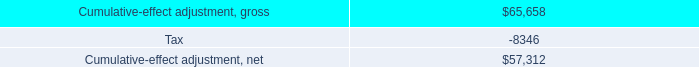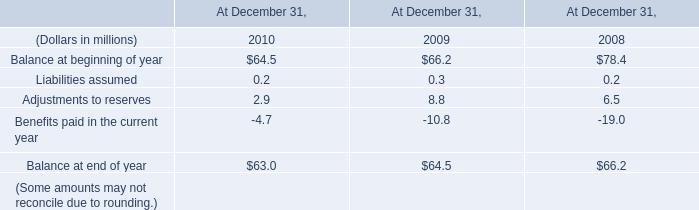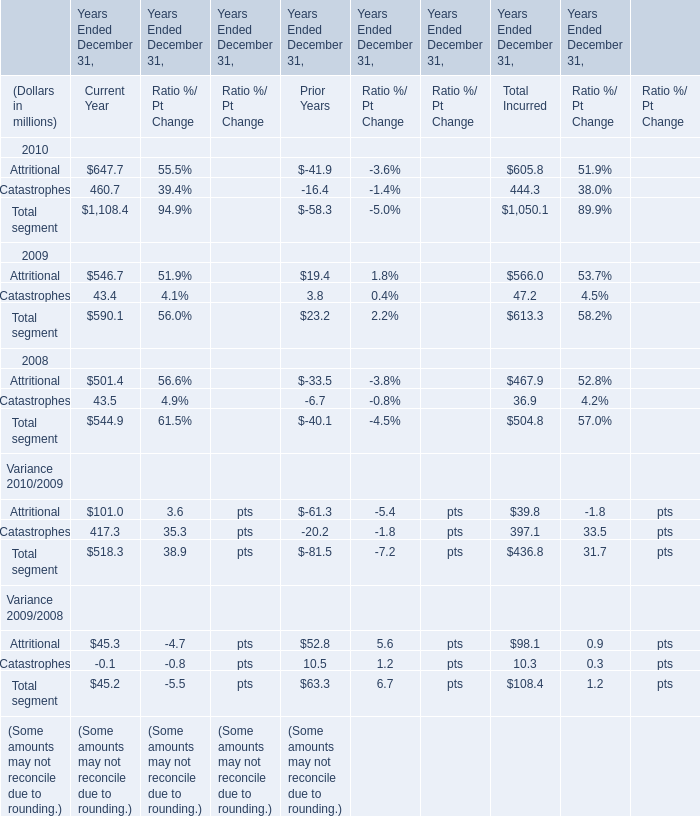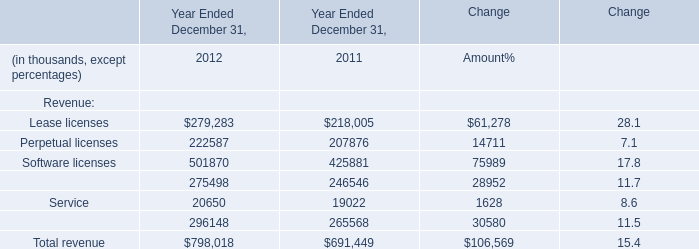What's the average of segment for current year in 2009? (in million) 
Computations: (590.1 / 2)
Answer: 295.05. 